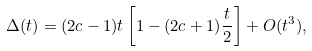Convert formula to latex. <formula><loc_0><loc_0><loc_500><loc_500>\Delta ( t ) = ( 2 c - 1 ) t \left [ 1 - ( 2 c + 1 ) \frac { t } { 2 } \right ] + O ( t ^ { 3 } ) ,</formula> 